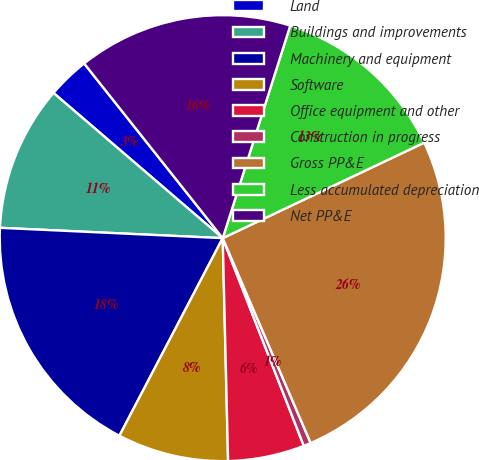Convert chart. <chart><loc_0><loc_0><loc_500><loc_500><pie_chart><fcel>Land<fcel>Buildings and improvements<fcel>Machinery and equipment<fcel>Software<fcel>Office equipment and other<fcel>Construction in progress<fcel>Gross PP&E<fcel>Less accumulated depreciation<fcel>Net PP&E<nl><fcel>3.04%<fcel>10.55%<fcel>18.07%<fcel>8.05%<fcel>5.54%<fcel>0.53%<fcel>25.59%<fcel>13.06%<fcel>15.57%<nl></chart> 